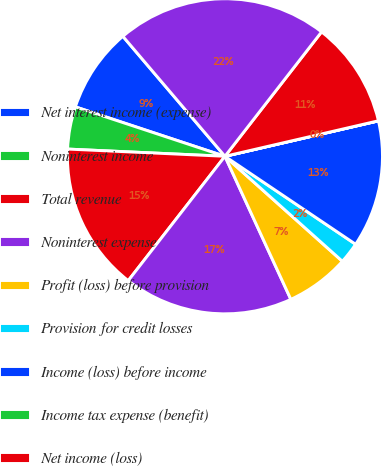Convert chart. <chart><loc_0><loc_0><loc_500><loc_500><pie_chart><fcel>Net interest income (expense)<fcel>Noninterest income<fcel>Total revenue<fcel>Noninterest expense<fcel>Profit (loss) before provision<fcel>Provision for credit losses<fcel>Income (loss) before income<fcel>Income tax expense (benefit)<fcel>Net income (loss)<fcel>Total Average Assets<nl><fcel>8.7%<fcel>4.35%<fcel>15.21%<fcel>17.39%<fcel>6.52%<fcel>2.18%<fcel>13.04%<fcel>0.01%<fcel>10.87%<fcel>21.73%<nl></chart> 